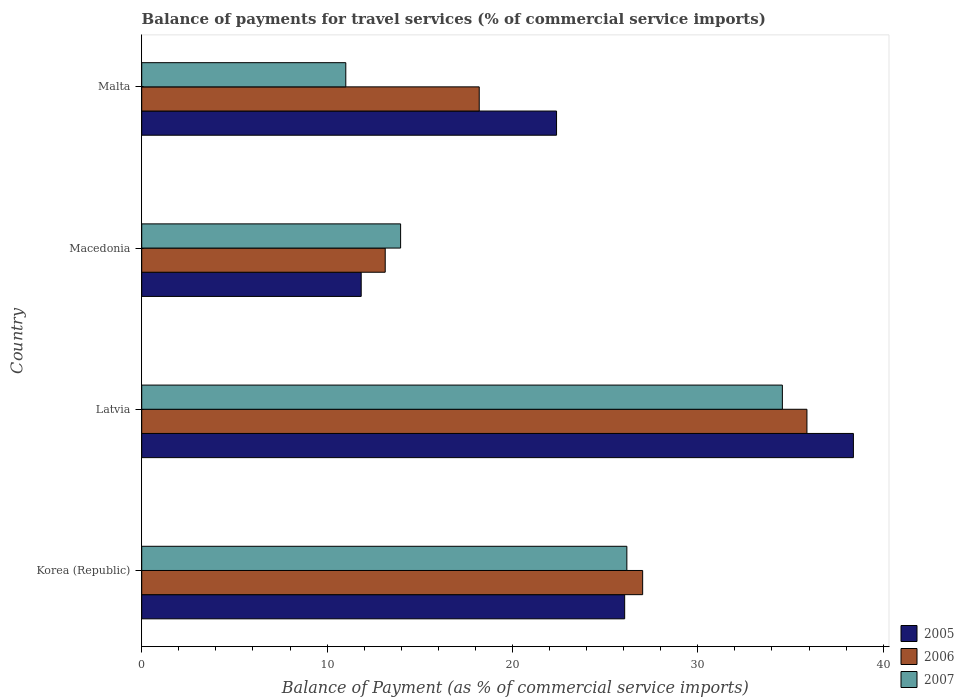How many groups of bars are there?
Keep it short and to the point. 4. Are the number of bars per tick equal to the number of legend labels?
Give a very brief answer. Yes. Are the number of bars on each tick of the Y-axis equal?
Ensure brevity in your answer.  Yes. How many bars are there on the 3rd tick from the top?
Keep it short and to the point. 3. What is the label of the 1st group of bars from the top?
Your answer should be compact. Malta. In how many cases, is the number of bars for a given country not equal to the number of legend labels?
Provide a succinct answer. 0. What is the balance of payments for travel services in 2007 in Malta?
Offer a very short reply. 11.01. Across all countries, what is the maximum balance of payments for travel services in 2006?
Offer a terse response. 35.89. Across all countries, what is the minimum balance of payments for travel services in 2006?
Offer a terse response. 13.14. In which country was the balance of payments for travel services in 2007 maximum?
Make the answer very short. Latvia. In which country was the balance of payments for travel services in 2006 minimum?
Make the answer very short. Macedonia. What is the total balance of payments for travel services in 2006 in the graph?
Your response must be concise. 94.26. What is the difference between the balance of payments for travel services in 2007 in Korea (Republic) and that in Macedonia?
Provide a succinct answer. 12.21. What is the difference between the balance of payments for travel services in 2006 in Macedonia and the balance of payments for travel services in 2005 in Korea (Republic)?
Keep it short and to the point. -12.92. What is the average balance of payments for travel services in 2005 per country?
Ensure brevity in your answer.  24.67. What is the difference between the balance of payments for travel services in 2006 and balance of payments for travel services in 2007 in Malta?
Offer a very short reply. 7.2. What is the ratio of the balance of payments for travel services in 2006 in Latvia to that in Malta?
Provide a succinct answer. 1.97. Is the balance of payments for travel services in 2005 in Korea (Republic) less than that in Macedonia?
Offer a very short reply. No. Is the difference between the balance of payments for travel services in 2006 in Macedonia and Malta greater than the difference between the balance of payments for travel services in 2007 in Macedonia and Malta?
Provide a short and direct response. No. What is the difference between the highest and the second highest balance of payments for travel services in 2006?
Give a very brief answer. 8.86. What is the difference between the highest and the lowest balance of payments for travel services in 2007?
Keep it short and to the point. 23.55. Is the sum of the balance of payments for travel services in 2007 in Latvia and Malta greater than the maximum balance of payments for travel services in 2005 across all countries?
Make the answer very short. Yes. Is it the case that in every country, the sum of the balance of payments for travel services in 2005 and balance of payments for travel services in 2006 is greater than the balance of payments for travel services in 2007?
Offer a terse response. Yes. Are all the bars in the graph horizontal?
Offer a very short reply. Yes. How many countries are there in the graph?
Your response must be concise. 4. Are the values on the major ticks of X-axis written in scientific E-notation?
Keep it short and to the point. No. Does the graph contain any zero values?
Provide a short and direct response. No. Where does the legend appear in the graph?
Make the answer very short. Bottom right. How many legend labels are there?
Your answer should be compact. 3. What is the title of the graph?
Provide a short and direct response. Balance of payments for travel services (% of commercial service imports). What is the label or title of the X-axis?
Your response must be concise. Balance of Payment (as % of commercial service imports). What is the label or title of the Y-axis?
Provide a succinct answer. Country. What is the Balance of Payment (as % of commercial service imports) in 2005 in Korea (Republic)?
Make the answer very short. 26.06. What is the Balance of Payment (as % of commercial service imports) in 2006 in Korea (Republic)?
Provide a short and direct response. 27.03. What is the Balance of Payment (as % of commercial service imports) of 2007 in Korea (Republic)?
Ensure brevity in your answer.  26.17. What is the Balance of Payment (as % of commercial service imports) of 2005 in Latvia?
Your answer should be compact. 38.4. What is the Balance of Payment (as % of commercial service imports) in 2006 in Latvia?
Provide a succinct answer. 35.89. What is the Balance of Payment (as % of commercial service imports) of 2007 in Latvia?
Offer a terse response. 34.56. What is the Balance of Payment (as % of commercial service imports) in 2005 in Macedonia?
Provide a short and direct response. 11.84. What is the Balance of Payment (as % of commercial service imports) of 2006 in Macedonia?
Provide a succinct answer. 13.14. What is the Balance of Payment (as % of commercial service imports) in 2007 in Macedonia?
Provide a short and direct response. 13.97. What is the Balance of Payment (as % of commercial service imports) in 2005 in Malta?
Your answer should be very brief. 22.38. What is the Balance of Payment (as % of commercial service imports) in 2006 in Malta?
Provide a succinct answer. 18.21. What is the Balance of Payment (as % of commercial service imports) of 2007 in Malta?
Offer a terse response. 11.01. Across all countries, what is the maximum Balance of Payment (as % of commercial service imports) of 2005?
Provide a succinct answer. 38.4. Across all countries, what is the maximum Balance of Payment (as % of commercial service imports) of 2006?
Keep it short and to the point. 35.89. Across all countries, what is the maximum Balance of Payment (as % of commercial service imports) of 2007?
Your response must be concise. 34.56. Across all countries, what is the minimum Balance of Payment (as % of commercial service imports) of 2005?
Ensure brevity in your answer.  11.84. Across all countries, what is the minimum Balance of Payment (as % of commercial service imports) in 2006?
Give a very brief answer. 13.14. Across all countries, what is the minimum Balance of Payment (as % of commercial service imports) in 2007?
Offer a terse response. 11.01. What is the total Balance of Payment (as % of commercial service imports) of 2005 in the graph?
Offer a terse response. 98.67. What is the total Balance of Payment (as % of commercial service imports) in 2006 in the graph?
Give a very brief answer. 94.26. What is the total Balance of Payment (as % of commercial service imports) in 2007 in the graph?
Keep it short and to the point. 85.71. What is the difference between the Balance of Payment (as % of commercial service imports) in 2005 in Korea (Republic) and that in Latvia?
Your answer should be compact. -12.34. What is the difference between the Balance of Payment (as % of commercial service imports) in 2006 in Korea (Republic) and that in Latvia?
Your answer should be compact. -8.86. What is the difference between the Balance of Payment (as % of commercial service imports) of 2007 in Korea (Republic) and that in Latvia?
Your answer should be compact. -8.39. What is the difference between the Balance of Payment (as % of commercial service imports) of 2005 in Korea (Republic) and that in Macedonia?
Your response must be concise. 14.21. What is the difference between the Balance of Payment (as % of commercial service imports) in 2006 in Korea (Republic) and that in Macedonia?
Keep it short and to the point. 13.89. What is the difference between the Balance of Payment (as % of commercial service imports) in 2007 in Korea (Republic) and that in Macedonia?
Your response must be concise. 12.21. What is the difference between the Balance of Payment (as % of commercial service imports) of 2005 in Korea (Republic) and that in Malta?
Offer a terse response. 3.68. What is the difference between the Balance of Payment (as % of commercial service imports) in 2006 in Korea (Republic) and that in Malta?
Provide a succinct answer. 8.82. What is the difference between the Balance of Payment (as % of commercial service imports) in 2007 in Korea (Republic) and that in Malta?
Offer a terse response. 15.16. What is the difference between the Balance of Payment (as % of commercial service imports) of 2005 in Latvia and that in Macedonia?
Provide a succinct answer. 26.55. What is the difference between the Balance of Payment (as % of commercial service imports) of 2006 in Latvia and that in Macedonia?
Provide a short and direct response. 22.75. What is the difference between the Balance of Payment (as % of commercial service imports) in 2007 in Latvia and that in Macedonia?
Your answer should be very brief. 20.6. What is the difference between the Balance of Payment (as % of commercial service imports) in 2005 in Latvia and that in Malta?
Offer a very short reply. 16.02. What is the difference between the Balance of Payment (as % of commercial service imports) of 2006 in Latvia and that in Malta?
Your response must be concise. 17.68. What is the difference between the Balance of Payment (as % of commercial service imports) of 2007 in Latvia and that in Malta?
Give a very brief answer. 23.55. What is the difference between the Balance of Payment (as % of commercial service imports) in 2005 in Macedonia and that in Malta?
Offer a terse response. -10.54. What is the difference between the Balance of Payment (as % of commercial service imports) in 2006 in Macedonia and that in Malta?
Give a very brief answer. -5.07. What is the difference between the Balance of Payment (as % of commercial service imports) in 2007 in Macedonia and that in Malta?
Keep it short and to the point. 2.96. What is the difference between the Balance of Payment (as % of commercial service imports) in 2005 in Korea (Republic) and the Balance of Payment (as % of commercial service imports) in 2006 in Latvia?
Provide a succinct answer. -9.83. What is the difference between the Balance of Payment (as % of commercial service imports) in 2005 in Korea (Republic) and the Balance of Payment (as % of commercial service imports) in 2007 in Latvia?
Provide a succinct answer. -8.51. What is the difference between the Balance of Payment (as % of commercial service imports) in 2006 in Korea (Republic) and the Balance of Payment (as % of commercial service imports) in 2007 in Latvia?
Make the answer very short. -7.54. What is the difference between the Balance of Payment (as % of commercial service imports) in 2005 in Korea (Republic) and the Balance of Payment (as % of commercial service imports) in 2006 in Macedonia?
Your response must be concise. 12.92. What is the difference between the Balance of Payment (as % of commercial service imports) of 2005 in Korea (Republic) and the Balance of Payment (as % of commercial service imports) of 2007 in Macedonia?
Keep it short and to the point. 12.09. What is the difference between the Balance of Payment (as % of commercial service imports) in 2006 in Korea (Republic) and the Balance of Payment (as % of commercial service imports) in 2007 in Macedonia?
Your answer should be compact. 13.06. What is the difference between the Balance of Payment (as % of commercial service imports) of 2005 in Korea (Republic) and the Balance of Payment (as % of commercial service imports) of 2006 in Malta?
Provide a succinct answer. 7.85. What is the difference between the Balance of Payment (as % of commercial service imports) of 2005 in Korea (Republic) and the Balance of Payment (as % of commercial service imports) of 2007 in Malta?
Make the answer very short. 15.04. What is the difference between the Balance of Payment (as % of commercial service imports) in 2006 in Korea (Republic) and the Balance of Payment (as % of commercial service imports) in 2007 in Malta?
Keep it short and to the point. 16.02. What is the difference between the Balance of Payment (as % of commercial service imports) in 2005 in Latvia and the Balance of Payment (as % of commercial service imports) in 2006 in Macedonia?
Offer a very short reply. 25.26. What is the difference between the Balance of Payment (as % of commercial service imports) of 2005 in Latvia and the Balance of Payment (as % of commercial service imports) of 2007 in Macedonia?
Provide a succinct answer. 24.43. What is the difference between the Balance of Payment (as % of commercial service imports) of 2006 in Latvia and the Balance of Payment (as % of commercial service imports) of 2007 in Macedonia?
Your response must be concise. 21.92. What is the difference between the Balance of Payment (as % of commercial service imports) in 2005 in Latvia and the Balance of Payment (as % of commercial service imports) in 2006 in Malta?
Keep it short and to the point. 20.19. What is the difference between the Balance of Payment (as % of commercial service imports) in 2005 in Latvia and the Balance of Payment (as % of commercial service imports) in 2007 in Malta?
Ensure brevity in your answer.  27.39. What is the difference between the Balance of Payment (as % of commercial service imports) in 2006 in Latvia and the Balance of Payment (as % of commercial service imports) in 2007 in Malta?
Give a very brief answer. 24.88. What is the difference between the Balance of Payment (as % of commercial service imports) in 2005 in Macedonia and the Balance of Payment (as % of commercial service imports) in 2006 in Malta?
Keep it short and to the point. -6.37. What is the difference between the Balance of Payment (as % of commercial service imports) of 2005 in Macedonia and the Balance of Payment (as % of commercial service imports) of 2007 in Malta?
Your answer should be compact. 0.83. What is the difference between the Balance of Payment (as % of commercial service imports) in 2006 in Macedonia and the Balance of Payment (as % of commercial service imports) in 2007 in Malta?
Give a very brief answer. 2.13. What is the average Balance of Payment (as % of commercial service imports) of 2005 per country?
Your answer should be very brief. 24.67. What is the average Balance of Payment (as % of commercial service imports) in 2006 per country?
Make the answer very short. 23.56. What is the average Balance of Payment (as % of commercial service imports) of 2007 per country?
Provide a short and direct response. 21.43. What is the difference between the Balance of Payment (as % of commercial service imports) in 2005 and Balance of Payment (as % of commercial service imports) in 2006 in Korea (Republic)?
Your answer should be compact. -0.97. What is the difference between the Balance of Payment (as % of commercial service imports) of 2005 and Balance of Payment (as % of commercial service imports) of 2007 in Korea (Republic)?
Your answer should be very brief. -0.12. What is the difference between the Balance of Payment (as % of commercial service imports) of 2006 and Balance of Payment (as % of commercial service imports) of 2007 in Korea (Republic)?
Ensure brevity in your answer.  0.85. What is the difference between the Balance of Payment (as % of commercial service imports) in 2005 and Balance of Payment (as % of commercial service imports) in 2006 in Latvia?
Offer a very short reply. 2.51. What is the difference between the Balance of Payment (as % of commercial service imports) in 2005 and Balance of Payment (as % of commercial service imports) in 2007 in Latvia?
Provide a succinct answer. 3.83. What is the difference between the Balance of Payment (as % of commercial service imports) in 2006 and Balance of Payment (as % of commercial service imports) in 2007 in Latvia?
Provide a succinct answer. 1.32. What is the difference between the Balance of Payment (as % of commercial service imports) of 2005 and Balance of Payment (as % of commercial service imports) of 2006 in Macedonia?
Provide a succinct answer. -1.3. What is the difference between the Balance of Payment (as % of commercial service imports) of 2005 and Balance of Payment (as % of commercial service imports) of 2007 in Macedonia?
Provide a short and direct response. -2.13. What is the difference between the Balance of Payment (as % of commercial service imports) of 2006 and Balance of Payment (as % of commercial service imports) of 2007 in Macedonia?
Provide a short and direct response. -0.83. What is the difference between the Balance of Payment (as % of commercial service imports) of 2005 and Balance of Payment (as % of commercial service imports) of 2006 in Malta?
Offer a very short reply. 4.17. What is the difference between the Balance of Payment (as % of commercial service imports) of 2005 and Balance of Payment (as % of commercial service imports) of 2007 in Malta?
Give a very brief answer. 11.37. What is the difference between the Balance of Payment (as % of commercial service imports) in 2006 and Balance of Payment (as % of commercial service imports) in 2007 in Malta?
Offer a very short reply. 7.2. What is the ratio of the Balance of Payment (as % of commercial service imports) in 2005 in Korea (Republic) to that in Latvia?
Provide a short and direct response. 0.68. What is the ratio of the Balance of Payment (as % of commercial service imports) in 2006 in Korea (Republic) to that in Latvia?
Ensure brevity in your answer.  0.75. What is the ratio of the Balance of Payment (as % of commercial service imports) of 2007 in Korea (Republic) to that in Latvia?
Your answer should be very brief. 0.76. What is the ratio of the Balance of Payment (as % of commercial service imports) in 2005 in Korea (Republic) to that in Macedonia?
Your answer should be very brief. 2.2. What is the ratio of the Balance of Payment (as % of commercial service imports) in 2006 in Korea (Republic) to that in Macedonia?
Give a very brief answer. 2.06. What is the ratio of the Balance of Payment (as % of commercial service imports) in 2007 in Korea (Republic) to that in Macedonia?
Your answer should be compact. 1.87. What is the ratio of the Balance of Payment (as % of commercial service imports) in 2005 in Korea (Republic) to that in Malta?
Provide a succinct answer. 1.16. What is the ratio of the Balance of Payment (as % of commercial service imports) of 2006 in Korea (Republic) to that in Malta?
Keep it short and to the point. 1.48. What is the ratio of the Balance of Payment (as % of commercial service imports) of 2007 in Korea (Republic) to that in Malta?
Your answer should be compact. 2.38. What is the ratio of the Balance of Payment (as % of commercial service imports) in 2005 in Latvia to that in Macedonia?
Make the answer very short. 3.24. What is the ratio of the Balance of Payment (as % of commercial service imports) in 2006 in Latvia to that in Macedonia?
Offer a terse response. 2.73. What is the ratio of the Balance of Payment (as % of commercial service imports) of 2007 in Latvia to that in Macedonia?
Your answer should be compact. 2.47. What is the ratio of the Balance of Payment (as % of commercial service imports) in 2005 in Latvia to that in Malta?
Offer a very short reply. 1.72. What is the ratio of the Balance of Payment (as % of commercial service imports) of 2006 in Latvia to that in Malta?
Make the answer very short. 1.97. What is the ratio of the Balance of Payment (as % of commercial service imports) in 2007 in Latvia to that in Malta?
Your answer should be very brief. 3.14. What is the ratio of the Balance of Payment (as % of commercial service imports) of 2005 in Macedonia to that in Malta?
Make the answer very short. 0.53. What is the ratio of the Balance of Payment (as % of commercial service imports) in 2006 in Macedonia to that in Malta?
Offer a terse response. 0.72. What is the ratio of the Balance of Payment (as % of commercial service imports) of 2007 in Macedonia to that in Malta?
Provide a succinct answer. 1.27. What is the difference between the highest and the second highest Balance of Payment (as % of commercial service imports) of 2005?
Your response must be concise. 12.34. What is the difference between the highest and the second highest Balance of Payment (as % of commercial service imports) in 2006?
Your answer should be compact. 8.86. What is the difference between the highest and the second highest Balance of Payment (as % of commercial service imports) in 2007?
Offer a terse response. 8.39. What is the difference between the highest and the lowest Balance of Payment (as % of commercial service imports) in 2005?
Make the answer very short. 26.55. What is the difference between the highest and the lowest Balance of Payment (as % of commercial service imports) of 2006?
Your answer should be very brief. 22.75. What is the difference between the highest and the lowest Balance of Payment (as % of commercial service imports) of 2007?
Provide a succinct answer. 23.55. 